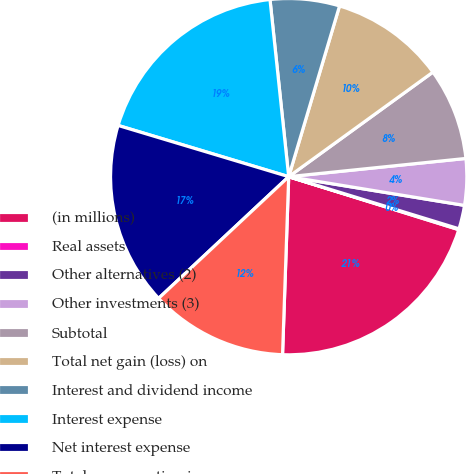Convert chart to OTSL. <chart><loc_0><loc_0><loc_500><loc_500><pie_chart><fcel>(in millions)<fcel>Real assets<fcel>Other alternatives (2)<fcel>Other investments (3)<fcel>Subtotal<fcel>Total net gain (loss) on<fcel>Interest and dividend income<fcel>Interest expense<fcel>Net interest expense<fcel>Total nonoperating income<nl><fcel>20.74%<fcel>0.08%<fcel>2.15%<fcel>4.21%<fcel>8.35%<fcel>10.41%<fcel>6.28%<fcel>18.68%<fcel>16.61%<fcel>12.48%<nl></chart> 